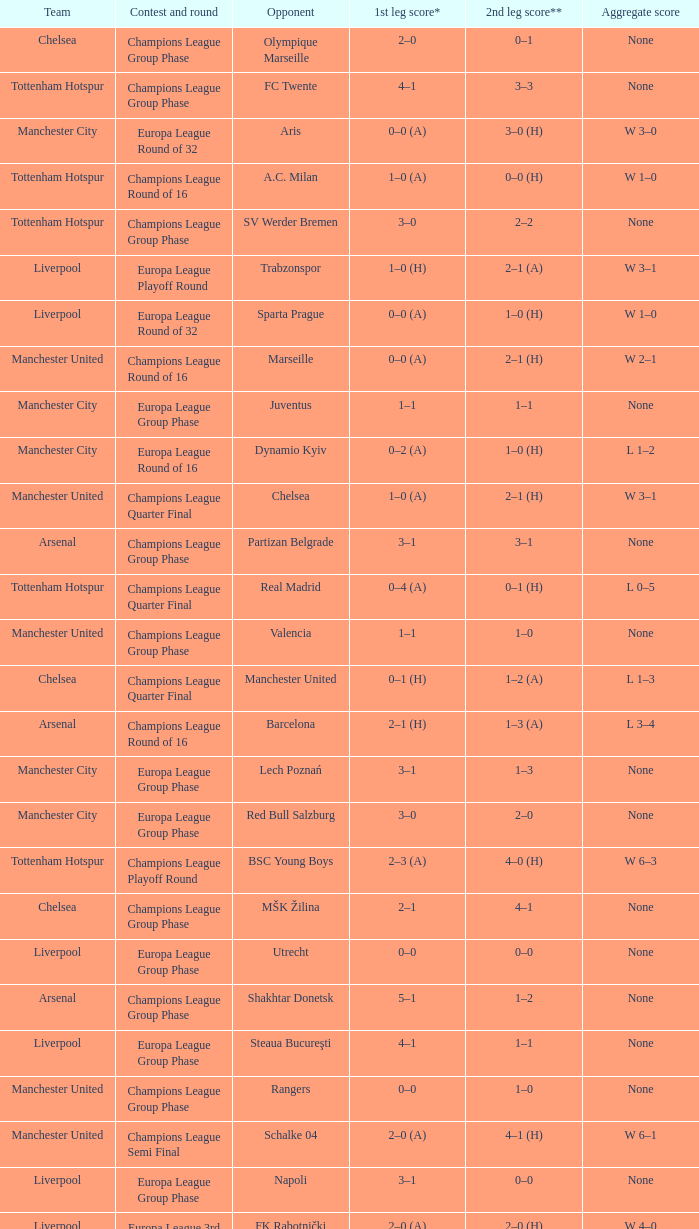How many goals did each one of the teams score in the first leg of the match between Liverpool and Trabzonspor? 1–0 (H). 